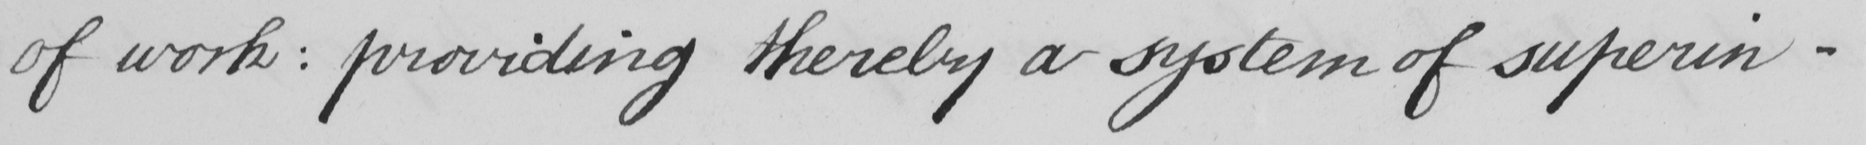What does this handwritten line say? of work :  providing thereby a system of superin- 